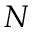<formula> <loc_0><loc_0><loc_500><loc_500>N</formula> 